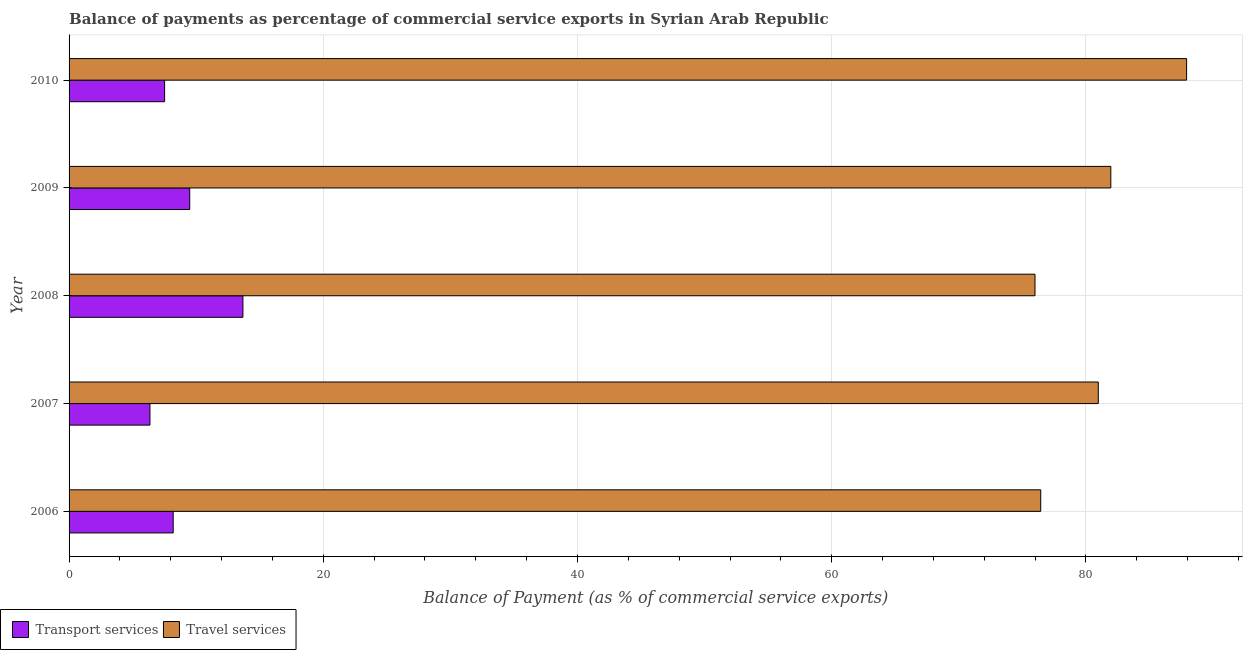Are the number of bars per tick equal to the number of legend labels?
Give a very brief answer. Yes. How many bars are there on the 5th tick from the top?
Provide a succinct answer. 2. What is the label of the 1st group of bars from the top?
Offer a terse response. 2010. In how many cases, is the number of bars for a given year not equal to the number of legend labels?
Provide a succinct answer. 0. What is the balance of payments of transport services in 2007?
Offer a terse response. 6.36. Across all years, what is the maximum balance of payments of travel services?
Ensure brevity in your answer.  87.92. Across all years, what is the minimum balance of payments of transport services?
Your answer should be compact. 6.36. In which year was the balance of payments of travel services maximum?
Keep it short and to the point. 2010. In which year was the balance of payments of transport services minimum?
Your response must be concise. 2007. What is the total balance of payments of travel services in the graph?
Your answer should be compact. 403.3. What is the difference between the balance of payments of transport services in 2006 and that in 2010?
Offer a very short reply. 0.68. What is the difference between the balance of payments of transport services in 2008 and the balance of payments of travel services in 2010?
Make the answer very short. -74.24. What is the average balance of payments of travel services per year?
Ensure brevity in your answer.  80.66. In the year 2006, what is the difference between the balance of payments of transport services and balance of payments of travel services?
Give a very brief answer. -68.25. What is the ratio of the balance of payments of travel services in 2008 to that in 2010?
Offer a very short reply. 0.86. What is the difference between the highest and the second highest balance of payments of transport services?
Provide a succinct answer. 4.19. What is the difference between the highest and the lowest balance of payments of transport services?
Provide a succinct answer. 7.32. In how many years, is the balance of payments of transport services greater than the average balance of payments of transport services taken over all years?
Your answer should be very brief. 2. Is the sum of the balance of payments of transport services in 2008 and 2010 greater than the maximum balance of payments of travel services across all years?
Your response must be concise. No. What does the 1st bar from the top in 2008 represents?
Provide a short and direct response. Travel services. What does the 1st bar from the bottom in 2008 represents?
Provide a succinct answer. Transport services. How many bars are there?
Provide a short and direct response. 10. Are all the bars in the graph horizontal?
Give a very brief answer. Yes. What is the difference between two consecutive major ticks on the X-axis?
Make the answer very short. 20. Are the values on the major ticks of X-axis written in scientific E-notation?
Your response must be concise. No. Where does the legend appear in the graph?
Provide a short and direct response. Bottom left. How many legend labels are there?
Offer a terse response. 2. What is the title of the graph?
Provide a short and direct response. Balance of payments as percentage of commercial service exports in Syrian Arab Republic. Does "Domestic Liabilities" appear as one of the legend labels in the graph?
Provide a succinct answer. No. What is the label or title of the X-axis?
Give a very brief answer. Balance of Payment (as % of commercial service exports). What is the label or title of the Y-axis?
Your answer should be compact. Year. What is the Balance of Payment (as % of commercial service exports) of Transport services in 2006?
Give a very brief answer. 8.19. What is the Balance of Payment (as % of commercial service exports) of Travel services in 2006?
Your answer should be very brief. 76.44. What is the Balance of Payment (as % of commercial service exports) in Transport services in 2007?
Give a very brief answer. 6.36. What is the Balance of Payment (as % of commercial service exports) in Travel services in 2007?
Your answer should be very brief. 80.97. What is the Balance of Payment (as % of commercial service exports) of Transport services in 2008?
Your answer should be compact. 13.68. What is the Balance of Payment (as % of commercial service exports) of Travel services in 2008?
Your answer should be very brief. 75.99. What is the Balance of Payment (as % of commercial service exports) in Transport services in 2009?
Ensure brevity in your answer.  9.49. What is the Balance of Payment (as % of commercial service exports) in Travel services in 2009?
Your answer should be very brief. 81.96. What is the Balance of Payment (as % of commercial service exports) in Transport services in 2010?
Make the answer very short. 7.52. What is the Balance of Payment (as % of commercial service exports) in Travel services in 2010?
Your answer should be compact. 87.92. Across all years, what is the maximum Balance of Payment (as % of commercial service exports) in Transport services?
Your answer should be very brief. 13.68. Across all years, what is the maximum Balance of Payment (as % of commercial service exports) in Travel services?
Your answer should be compact. 87.92. Across all years, what is the minimum Balance of Payment (as % of commercial service exports) in Transport services?
Ensure brevity in your answer.  6.36. Across all years, what is the minimum Balance of Payment (as % of commercial service exports) of Travel services?
Provide a succinct answer. 75.99. What is the total Balance of Payment (as % of commercial service exports) in Transport services in the graph?
Give a very brief answer. 45.24. What is the total Balance of Payment (as % of commercial service exports) in Travel services in the graph?
Give a very brief answer. 403.3. What is the difference between the Balance of Payment (as % of commercial service exports) of Transport services in 2006 and that in 2007?
Keep it short and to the point. 1.83. What is the difference between the Balance of Payment (as % of commercial service exports) of Travel services in 2006 and that in 2007?
Provide a succinct answer. -4.53. What is the difference between the Balance of Payment (as % of commercial service exports) of Transport services in 2006 and that in 2008?
Your response must be concise. -5.49. What is the difference between the Balance of Payment (as % of commercial service exports) of Travel services in 2006 and that in 2008?
Provide a short and direct response. 0.45. What is the difference between the Balance of Payment (as % of commercial service exports) in Transport services in 2006 and that in 2009?
Your answer should be compact. -1.3. What is the difference between the Balance of Payment (as % of commercial service exports) of Travel services in 2006 and that in 2009?
Ensure brevity in your answer.  -5.52. What is the difference between the Balance of Payment (as % of commercial service exports) in Transport services in 2006 and that in 2010?
Provide a succinct answer. 0.68. What is the difference between the Balance of Payment (as % of commercial service exports) of Travel services in 2006 and that in 2010?
Give a very brief answer. -11.48. What is the difference between the Balance of Payment (as % of commercial service exports) in Transport services in 2007 and that in 2008?
Ensure brevity in your answer.  -7.32. What is the difference between the Balance of Payment (as % of commercial service exports) of Travel services in 2007 and that in 2008?
Keep it short and to the point. 4.98. What is the difference between the Balance of Payment (as % of commercial service exports) of Transport services in 2007 and that in 2009?
Keep it short and to the point. -3.13. What is the difference between the Balance of Payment (as % of commercial service exports) of Travel services in 2007 and that in 2009?
Give a very brief answer. -0.99. What is the difference between the Balance of Payment (as % of commercial service exports) of Transport services in 2007 and that in 2010?
Provide a succinct answer. -1.15. What is the difference between the Balance of Payment (as % of commercial service exports) in Travel services in 2007 and that in 2010?
Give a very brief answer. -6.95. What is the difference between the Balance of Payment (as % of commercial service exports) of Transport services in 2008 and that in 2009?
Offer a very short reply. 4.19. What is the difference between the Balance of Payment (as % of commercial service exports) of Travel services in 2008 and that in 2009?
Give a very brief answer. -5.96. What is the difference between the Balance of Payment (as % of commercial service exports) in Transport services in 2008 and that in 2010?
Ensure brevity in your answer.  6.16. What is the difference between the Balance of Payment (as % of commercial service exports) of Travel services in 2008 and that in 2010?
Keep it short and to the point. -11.93. What is the difference between the Balance of Payment (as % of commercial service exports) in Transport services in 2009 and that in 2010?
Your answer should be compact. 1.98. What is the difference between the Balance of Payment (as % of commercial service exports) of Travel services in 2009 and that in 2010?
Ensure brevity in your answer.  -5.96. What is the difference between the Balance of Payment (as % of commercial service exports) in Transport services in 2006 and the Balance of Payment (as % of commercial service exports) in Travel services in 2007?
Provide a short and direct response. -72.78. What is the difference between the Balance of Payment (as % of commercial service exports) of Transport services in 2006 and the Balance of Payment (as % of commercial service exports) of Travel services in 2008?
Your answer should be very brief. -67.8. What is the difference between the Balance of Payment (as % of commercial service exports) of Transport services in 2006 and the Balance of Payment (as % of commercial service exports) of Travel services in 2009?
Make the answer very short. -73.77. What is the difference between the Balance of Payment (as % of commercial service exports) of Transport services in 2006 and the Balance of Payment (as % of commercial service exports) of Travel services in 2010?
Provide a succinct answer. -79.73. What is the difference between the Balance of Payment (as % of commercial service exports) in Transport services in 2007 and the Balance of Payment (as % of commercial service exports) in Travel services in 2008?
Keep it short and to the point. -69.63. What is the difference between the Balance of Payment (as % of commercial service exports) in Transport services in 2007 and the Balance of Payment (as % of commercial service exports) in Travel services in 2009?
Make the answer very short. -75.6. What is the difference between the Balance of Payment (as % of commercial service exports) in Transport services in 2007 and the Balance of Payment (as % of commercial service exports) in Travel services in 2010?
Keep it short and to the point. -81.56. What is the difference between the Balance of Payment (as % of commercial service exports) of Transport services in 2008 and the Balance of Payment (as % of commercial service exports) of Travel services in 2009?
Your answer should be very brief. -68.28. What is the difference between the Balance of Payment (as % of commercial service exports) of Transport services in 2008 and the Balance of Payment (as % of commercial service exports) of Travel services in 2010?
Your response must be concise. -74.24. What is the difference between the Balance of Payment (as % of commercial service exports) of Transport services in 2009 and the Balance of Payment (as % of commercial service exports) of Travel services in 2010?
Give a very brief answer. -78.43. What is the average Balance of Payment (as % of commercial service exports) in Transport services per year?
Keep it short and to the point. 9.05. What is the average Balance of Payment (as % of commercial service exports) of Travel services per year?
Your answer should be very brief. 80.66. In the year 2006, what is the difference between the Balance of Payment (as % of commercial service exports) of Transport services and Balance of Payment (as % of commercial service exports) of Travel services?
Offer a terse response. -68.25. In the year 2007, what is the difference between the Balance of Payment (as % of commercial service exports) of Transport services and Balance of Payment (as % of commercial service exports) of Travel services?
Make the answer very short. -74.61. In the year 2008, what is the difference between the Balance of Payment (as % of commercial service exports) of Transport services and Balance of Payment (as % of commercial service exports) of Travel services?
Offer a terse response. -62.32. In the year 2009, what is the difference between the Balance of Payment (as % of commercial service exports) in Transport services and Balance of Payment (as % of commercial service exports) in Travel services?
Your answer should be very brief. -72.47. In the year 2010, what is the difference between the Balance of Payment (as % of commercial service exports) in Transport services and Balance of Payment (as % of commercial service exports) in Travel services?
Your response must be concise. -80.41. What is the ratio of the Balance of Payment (as % of commercial service exports) in Transport services in 2006 to that in 2007?
Your answer should be very brief. 1.29. What is the ratio of the Balance of Payment (as % of commercial service exports) in Travel services in 2006 to that in 2007?
Provide a short and direct response. 0.94. What is the ratio of the Balance of Payment (as % of commercial service exports) of Transport services in 2006 to that in 2008?
Your answer should be compact. 0.6. What is the ratio of the Balance of Payment (as % of commercial service exports) in Travel services in 2006 to that in 2008?
Keep it short and to the point. 1.01. What is the ratio of the Balance of Payment (as % of commercial service exports) of Transport services in 2006 to that in 2009?
Give a very brief answer. 0.86. What is the ratio of the Balance of Payment (as % of commercial service exports) in Travel services in 2006 to that in 2009?
Your answer should be compact. 0.93. What is the ratio of the Balance of Payment (as % of commercial service exports) of Transport services in 2006 to that in 2010?
Offer a terse response. 1.09. What is the ratio of the Balance of Payment (as % of commercial service exports) in Travel services in 2006 to that in 2010?
Provide a short and direct response. 0.87. What is the ratio of the Balance of Payment (as % of commercial service exports) in Transport services in 2007 to that in 2008?
Your response must be concise. 0.47. What is the ratio of the Balance of Payment (as % of commercial service exports) in Travel services in 2007 to that in 2008?
Your answer should be compact. 1.07. What is the ratio of the Balance of Payment (as % of commercial service exports) of Transport services in 2007 to that in 2009?
Your answer should be compact. 0.67. What is the ratio of the Balance of Payment (as % of commercial service exports) of Travel services in 2007 to that in 2009?
Provide a short and direct response. 0.99. What is the ratio of the Balance of Payment (as % of commercial service exports) of Transport services in 2007 to that in 2010?
Offer a very short reply. 0.85. What is the ratio of the Balance of Payment (as % of commercial service exports) in Travel services in 2007 to that in 2010?
Ensure brevity in your answer.  0.92. What is the ratio of the Balance of Payment (as % of commercial service exports) in Transport services in 2008 to that in 2009?
Offer a very short reply. 1.44. What is the ratio of the Balance of Payment (as % of commercial service exports) in Travel services in 2008 to that in 2009?
Make the answer very short. 0.93. What is the ratio of the Balance of Payment (as % of commercial service exports) in Transport services in 2008 to that in 2010?
Provide a succinct answer. 1.82. What is the ratio of the Balance of Payment (as % of commercial service exports) in Travel services in 2008 to that in 2010?
Keep it short and to the point. 0.86. What is the ratio of the Balance of Payment (as % of commercial service exports) of Transport services in 2009 to that in 2010?
Make the answer very short. 1.26. What is the ratio of the Balance of Payment (as % of commercial service exports) in Travel services in 2009 to that in 2010?
Your answer should be compact. 0.93. What is the difference between the highest and the second highest Balance of Payment (as % of commercial service exports) of Transport services?
Give a very brief answer. 4.19. What is the difference between the highest and the second highest Balance of Payment (as % of commercial service exports) in Travel services?
Offer a very short reply. 5.96. What is the difference between the highest and the lowest Balance of Payment (as % of commercial service exports) of Transport services?
Ensure brevity in your answer.  7.32. What is the difference between the highest and the lowest Balance of Payment (as % of commercial service exports) of Travel services?
Your answer should be very brief. 11.93. 